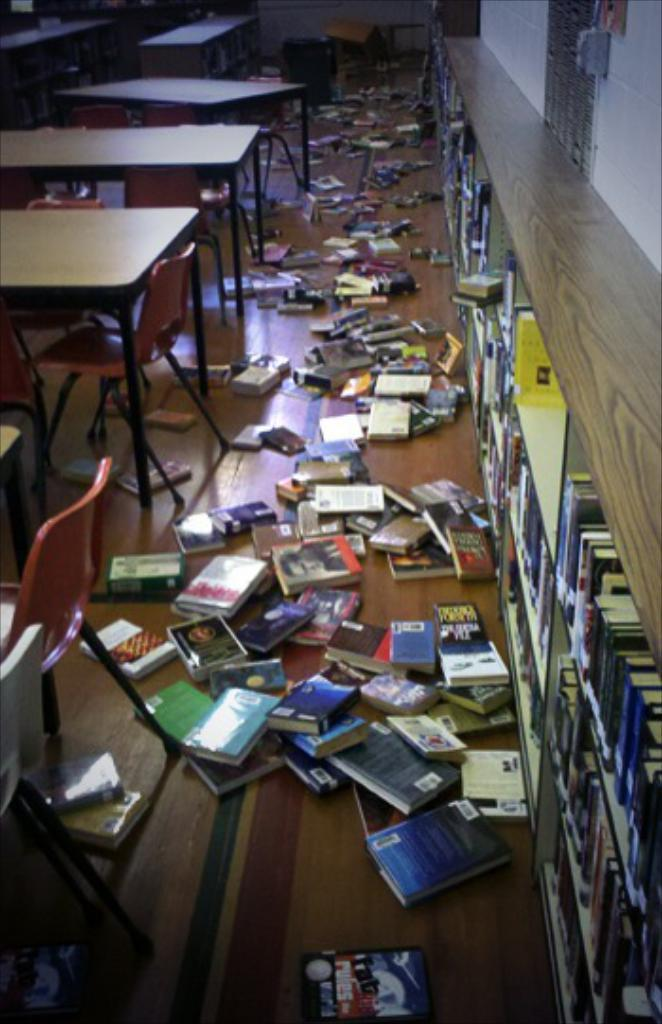What type of furniture is present in the image? There are tables and chairs in the image. What can be found on the tables in the image? Books are present on the tables in the image. What is on the floor in the image? There are objects on the floor in the image. Where are the books located on the right side of the image? Books are on racks on the right side of the image. What is visible on the right side of the image besides the books? There are other objects on the right side of the image. What is the background of the image? There is a wall visible in the image. Can you see any fish swimming in the image? There are no fish present in the image. What type of protest is happening in the image? There is no protest depicted in the image. 